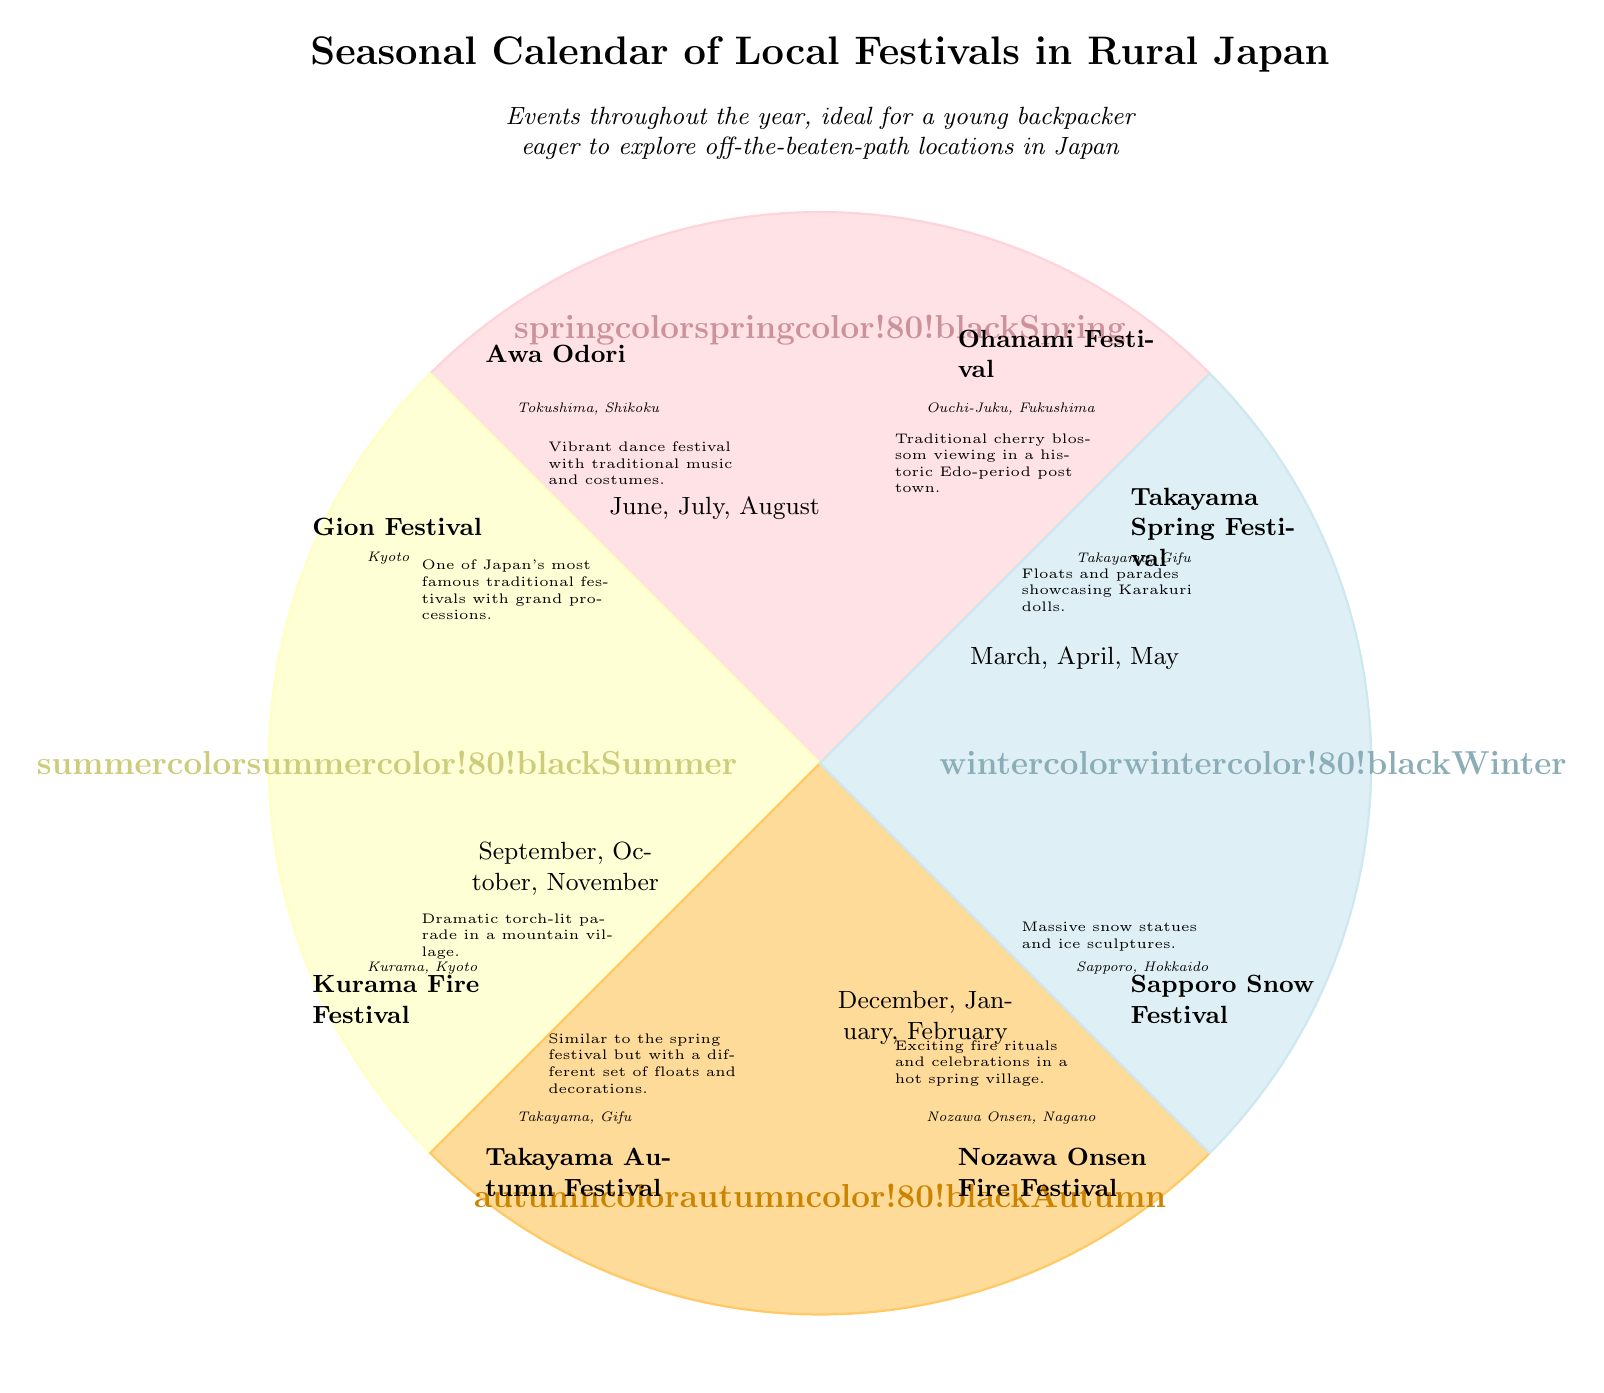What is the main title of the diagram? The title of the diagram is displayed prominently at the top, stating "Seasonal Calendar of Local Festivals in Rural Japan."
Answer: Seasonal Calendar of Local Festivals in Rural Japan Which season is represented in the southeast section? The southeast section is associated with the angle of 225 degrees, which corresponds to the autumn season.
Answer: Autumn How many months are shown in the winter section of the diagram? The winter section is represented by the months listed at 292.5 degrees: December, January, and February, which totals three months.
Answer: 3 What festival is held in Takayama during spring? The spring festival held in Takayama is named "Takayama Spring Festival," which is clearly indicated in the corresponding section of the diagram.
Answer: Takayama Spring Festival Which festival is related to cherry blossoms? The festival associated with cherry blossoms, represented at 60 degrees, is the "Ohanami Festival" located in Ouchi-Juku, Fukushima.
Answer: Ohanami Festival Which two festivals occur in Takayama? There are two festivals in Takayama: "Takayama Spring Festival" in spring and "Takayama Autumn Festival" in autumn, as described in the respective sections of the diagram.
Answer: Takayama Spring Festival, Takayama Autumn Festival What is the location of the Gion Festival? The Gion Festival is located in Kyoto, which is mentioned directly below the festival name in the festival section on the diagram.
Answer: Kyoto Describe the festival that occurs in Nozawa Onsen. The "Nozawa Onsen Fire Festival," located in Nozawa Onsen, Nagano, involves exciting fire rituals and celebrations in a hot spring village, as noted in the diagram.
Answer: Exciting fire rituals and celebrations in a hot spring village How many total festivals are listed in the diagram? There are a total of eight festivals highlighted in the diagram, seen scattered throughout the seasonal sections, which can be counted sequentially.
Answer: 8 